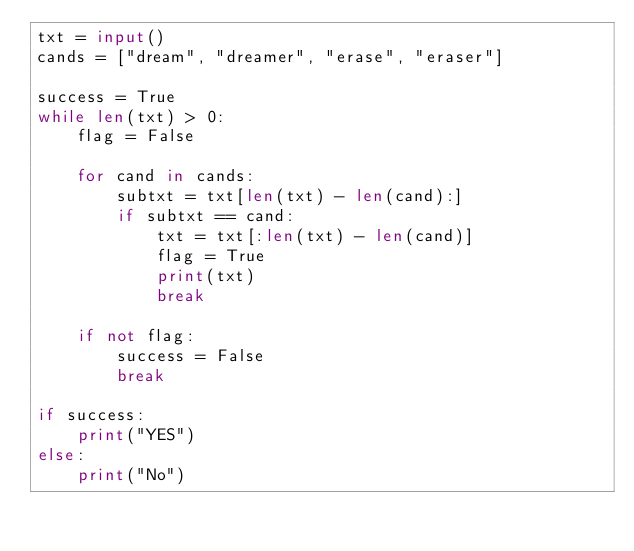<code> <loc_0><loc_0><loc_500><loc_500><_Python_>txt = input()
cands = ["dream", "dreamer", "erase", "eraser"]

success = True
while len(txt) > 0:
    flag = False

    for cand in cands:
        subtxt = txt[len(txt) - len(cand):]
        if subtxt == cand:
            txt = txt[:len(txt) - len(cand)]
            flag = True
            print(txt)
            break

    if not flag:
        success = False
        break

if success:
    print("YES")
else:
    print("No")</code> 